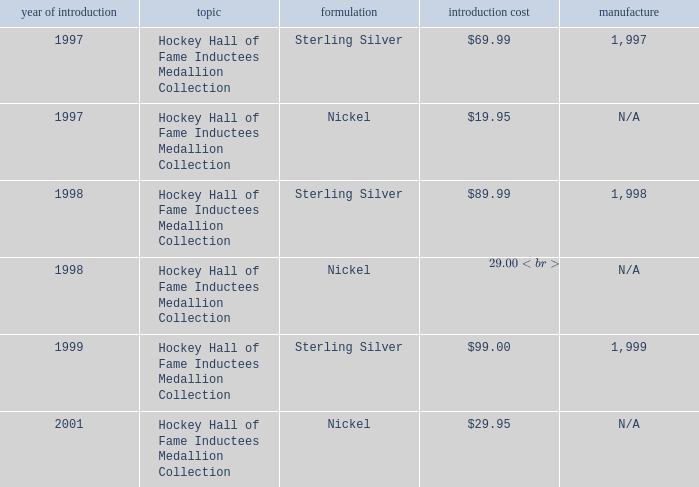Which composition has an issue price of $99.00? Sterling Silver. 